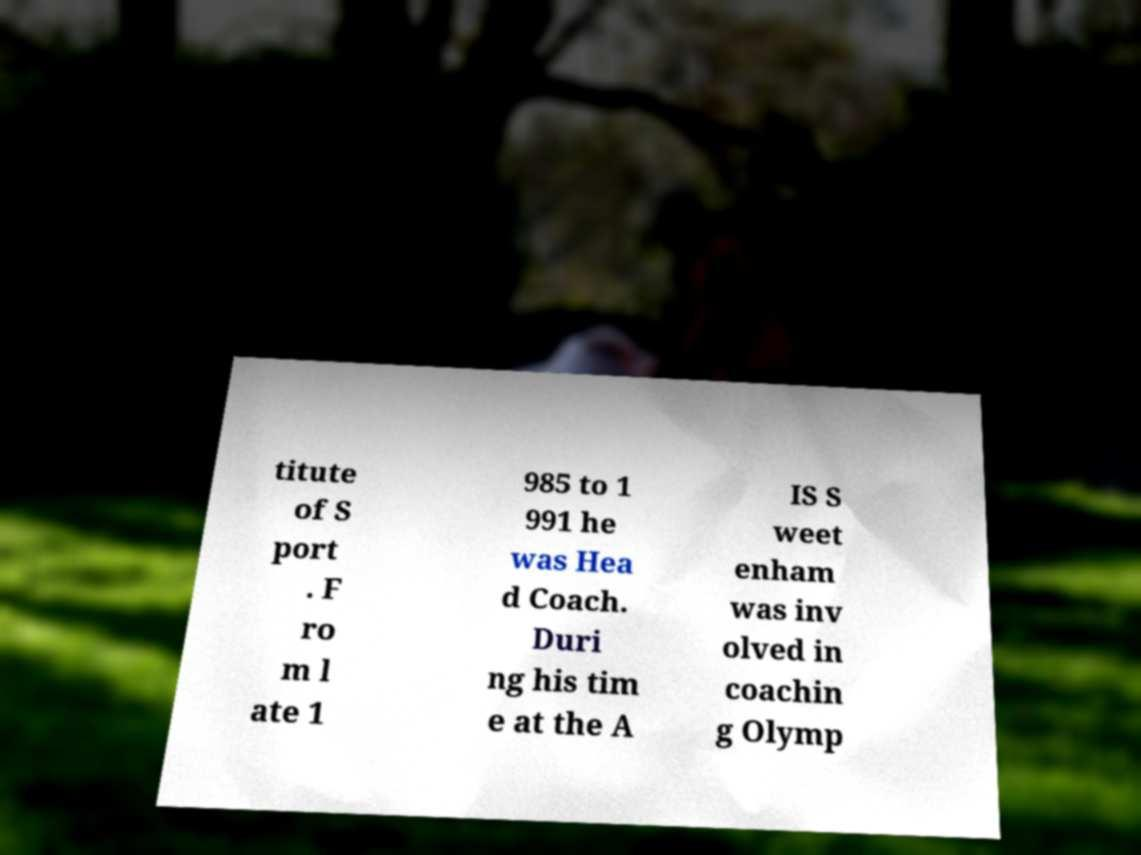Could you assist in decoding the text presented in this image and type it out clearly? titute of S port . F ro m l ate 1 985 to 1 991 he was Hea d Coach. Duri ng his tim e at the A IS S weet enham was inv olved in coachin g Olymp 